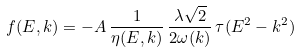Convert formula to latex. <formula><loc_0><loc_0><loc_500><loc_500>f ( E , { k } ) = - A \, \frac { 1 } { \eta ( E , { k } ) } \, \frac { \lambda \sqrt { 2 } } { 2 \omega ( { k } ) } \, \tau ( E ^ { 2 } - { k } ^ { 2 } )</formula> 